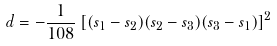Convert formula to latex. <formula><loc_0><loc_0><loc_500><loc_500>d = - \frac { 1 } { 1 0 8 } \left [ ( s _ { 1 } - s _ { 2 } ) ( s _ { 2 } - s _ { 3 } ) ( s _ { 3 } - s _ { 1 } ) \right ] ^ { 2 }</formula> 